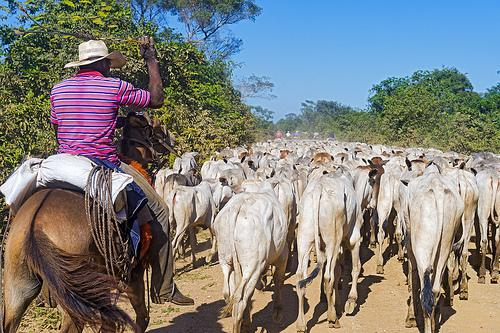Question: what is the herd of?
Choices:
A. Horses.
B. Sheep.
C. Cattle.
D. Cow.
Answer with the letter. Answer: C Question: what pattern shirt is visible?
Choices:
A. Plaid.
B. Checkered.
C. Polka-dotted.
D. Stripped.
Answer with the letter. Answer: D Question: where are the cattle headed in the image?
Choices:
A. Toward the water.
B. Away.
C. Toward the mountain.
D. Toward the pasture.
Answer with the letter. Answer: B Question: what is this called?
Choices:
A. A portrait.
B. Water fountain.
C. Dog.
D. Cattle drive.
Answer with the letter. Answer: D Question: what is the man riding?
Choices:
A. Horse.
B. Bike.
C. Motorcycle.
D. Bull.
Answer with the letter. Answer: A Question: how many people are easily visible?
Choices:
A. 2.
B. 3.
C. 1.
D. 4.
Answer with the letter. Answer: C 